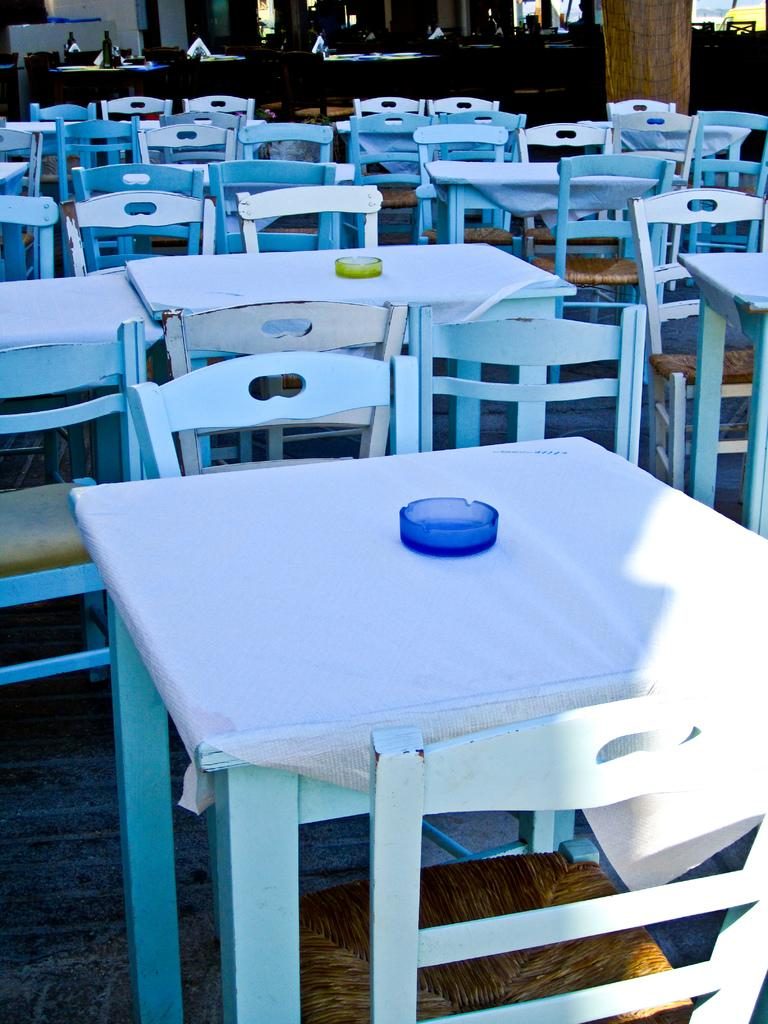What type of furniture is present in the image? There are many tables and chairs in the image. What can be found on the tables? There are cups on the tables. Are there any objects on the table at the top of the image? Yes, there are objects on the table at the top of the image. What type of cloth is draped over the snake in the image? There is no snake or cloth present in the image. What might surprise the people sitting at the tables in the image? The image does not provide any information about what might surprise the people sitting at the tables. 